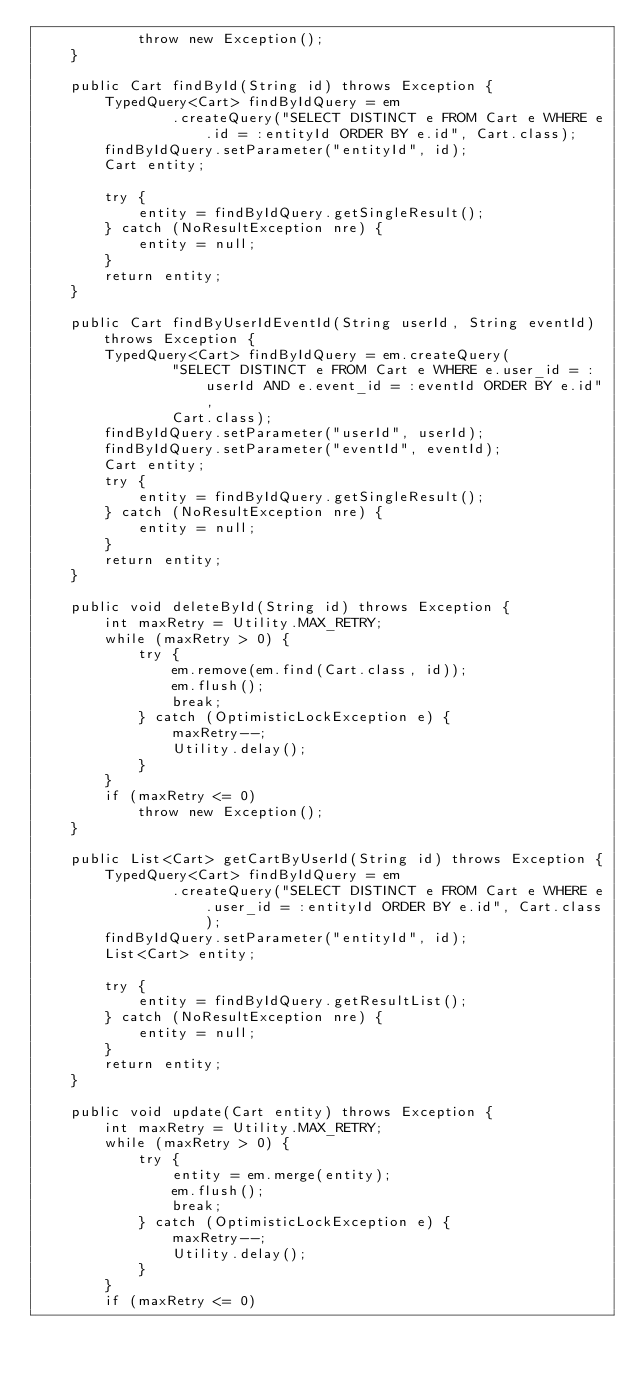Convert code to text. <code><loc_0><loc_0><loc_500><loc_500><_Java_>			throw new Exception();
	}

	public Cart findById(String id) throws Exception {
		TypedQuery<Cart> findByIdQuery = em
				.createQuery("SELECT DISTINCT e FROM Cart e WHERE e.id = :entityId ORDER BY e.id", Cart.class);
		findByIdQuery.setParameter("entityId", id);
		Cart entity;

		try {
			entity = findByIdQuery.getSingleResult();
		} catch (NoResultException nre) {
			entity = null;
		}
		return entity;
	}

	public Cart findByUserIdEventId(String userId, String eventId) throws Exception {
		TypedQuery<Cart> findByIdQuery = em.createQuery(
				"SELECT DISTINCT e FROM Cart e WHERE e.user_id = :userId AND e.event_id = :eventId ORDER BY e.id",
				Cart.class);
		findByIdQuery.setParameter("userId", userId);
		findByIdQuery.setParameter("eventId", eventId);
		Cart entity;
		try {
			entity = findByIdQuery.getSingleResult();
		} catch (NoResultException nre) {
			entity = null;
		}
		return entity;
	}

	public void deleteById(String id) throws Exception {
		int maxRetry = Utility.MAX_RETRY;
		while (maxRetry > 0) {
			try {
				em.remove(em.find(Cart.class, id));
				em.flush();
				break;
			} catch (OptimisticLockException e) {
				maxRetry--;
				Utility.delay();
			}
		}
		if (maxRetry <= 0)
			throw new Exception();
	}

	public List<Cart> getCartByUserId(String id) throws Exception {
		TypedQuery<Cart> findByIdQuery = em
				.createQuery("SELECT DISTINCT e FROM Cart e WHERE e.user_id = :entityId ORDER BY e.id", Cart.class);
		findByIdQuery.setParameter("entityId", id);
		List<Cart> entity;

		try {
			entity = findByIdQuery.getResultList();
		} catch (NoResultException nre) {
			entity = null;
		}
		return entity;
	}

	public void update(Cart entity) throws Exception {
		int maxRetry = Utility.MAX_RETRY;
		while (maxRetry > 0) {
			try {
				entity = em.merge(entity);
				em.flush();
				break;
			} catch (OptimisticLockException e) {
				maxRetry--;
				Utility.delay();
			}
		}
		if (maxRetry <= 0)</code> 